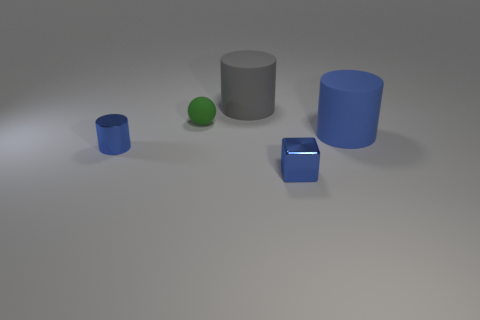Subtract 1 cylinders. How many cylinders are left? 2 Add 3 gray metal balls. How many objects exist? 8 Subtract all spheres. How many objects are left? 4 Add 5 red shiny objects. How many red shiny objects exist? 5 Subtract 0 yellow cylinders. How many objects are left? 5 Subtract all green matte spheres. Subtract all big blue rubber things. How many objects are left? 3 Add 5 small blue cylinders. How many small blue cylinders are left? 6 